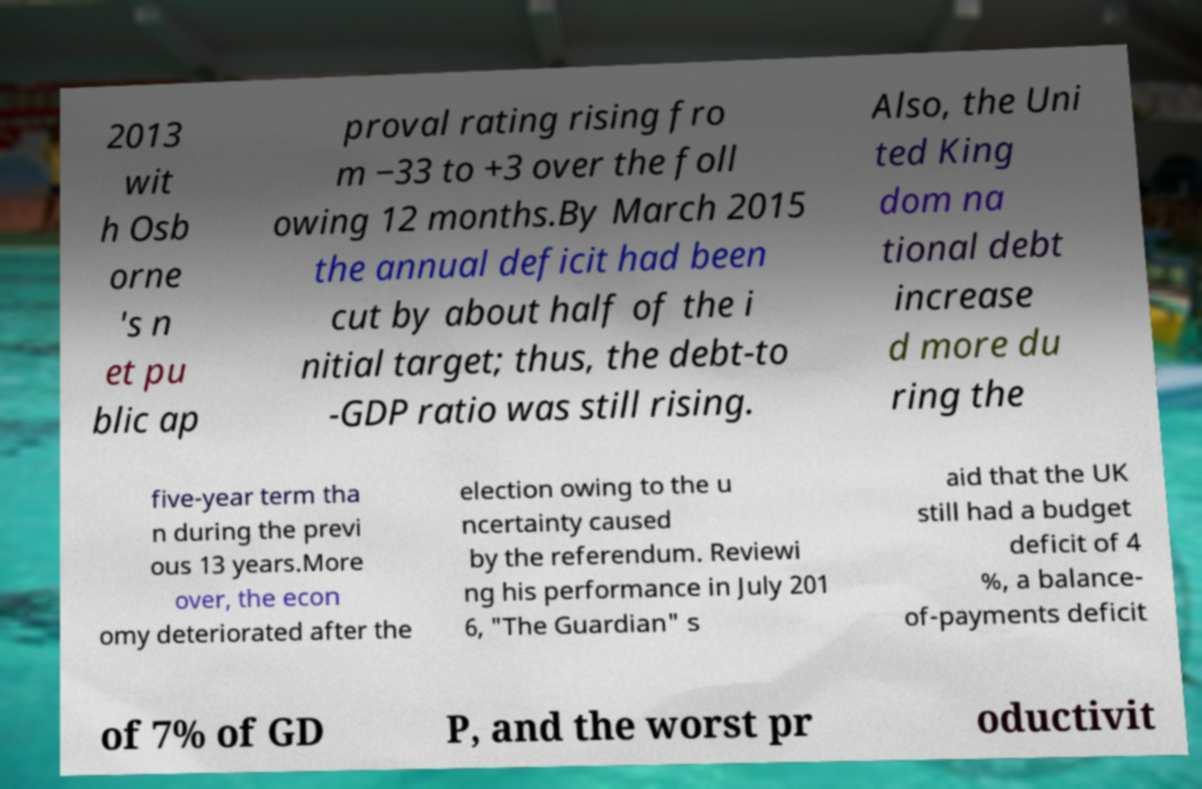Could you assist in decoding the text presented in this image and type it out clearly? 2013 wit h Osb orne 's n et pu blic ap proval rating rising fro m −33 to +3 over the foll owing 12 months.By March 2015 the annual deficit had been cut by about half of the i nitial target; thus, the debt-to -GDP ratio was still rising. Also, the Uni ted King dom na tional debt increase d more du ring the five-year term tha n during the previ ous 13 years.More over, the econ omy deteriorated after the election owing to the u ncertainty caused by the referendum. Reviewi ng his performance in July 201 6, "The Guardian" s aid that the UK still had a budget deficit of 4 %, a balance- of-payments deficit of 7% of GD P, and the worst pr oductivit 